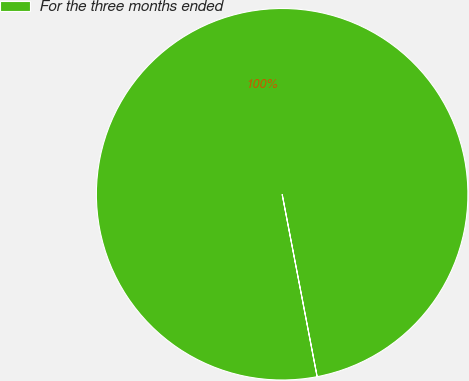<chart> <loc_0><loc_0><loc_500><loc_500><pie_chart><fcel>For the three months ended<nl><fcel>100.0%<nl></chart> 